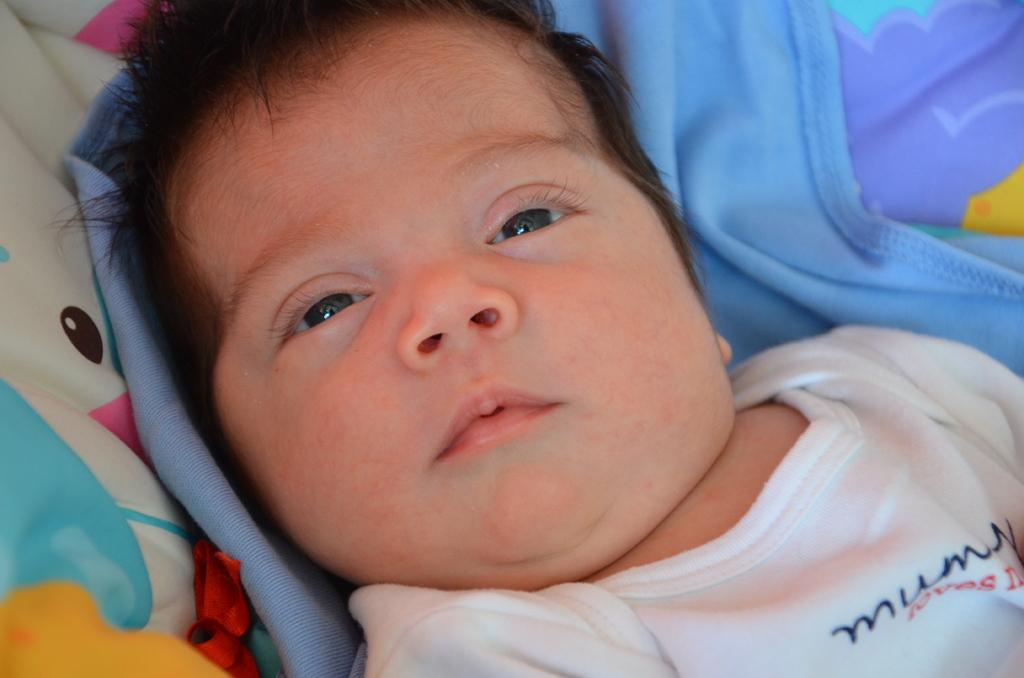What is the main subject of the image? The main subject of the image is a baby. Where is the baby located in the image? The baby is on a bed. How much does the baby weigh in the image? The weight of the baby cannot be determined from the image. 